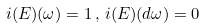<formula> <loc_0><loc_0><loc_500><loc_500>i ( E ) ( \omega ) = 1 \, , \, i ( E ) ( d \omega ) = 0</formula> 